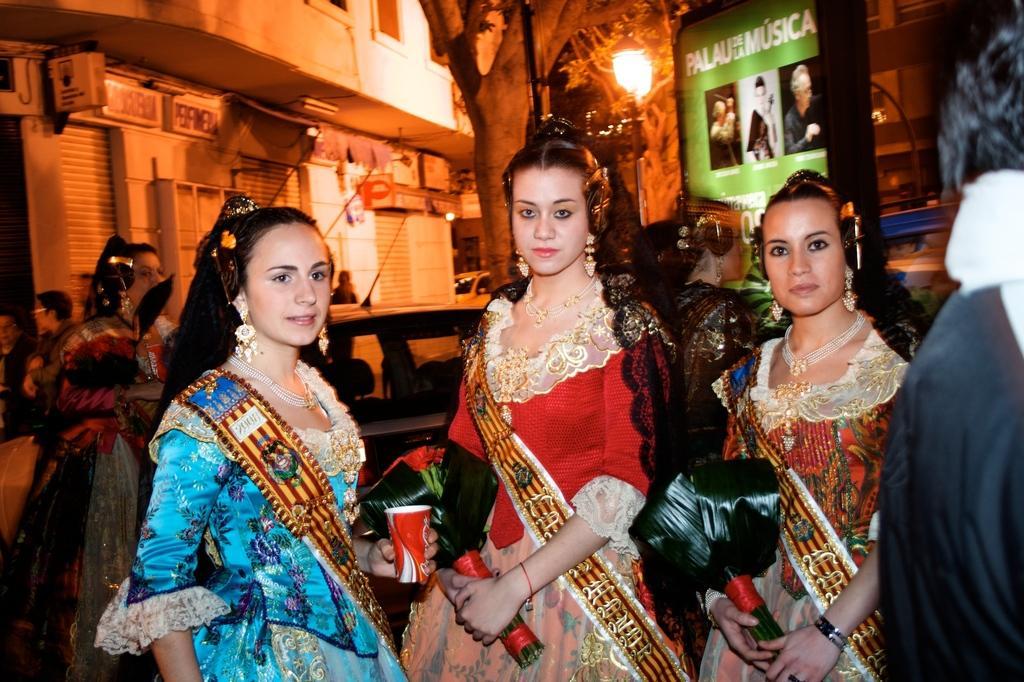Could you give a brief overview of what you see in this image? In this image there are three women standing, two are holding bookies in their hand and one is holding cock in her hand, in the background there are few people standing and there is a car, tree, building, light pole and poster, on the right side there is a man standing. 